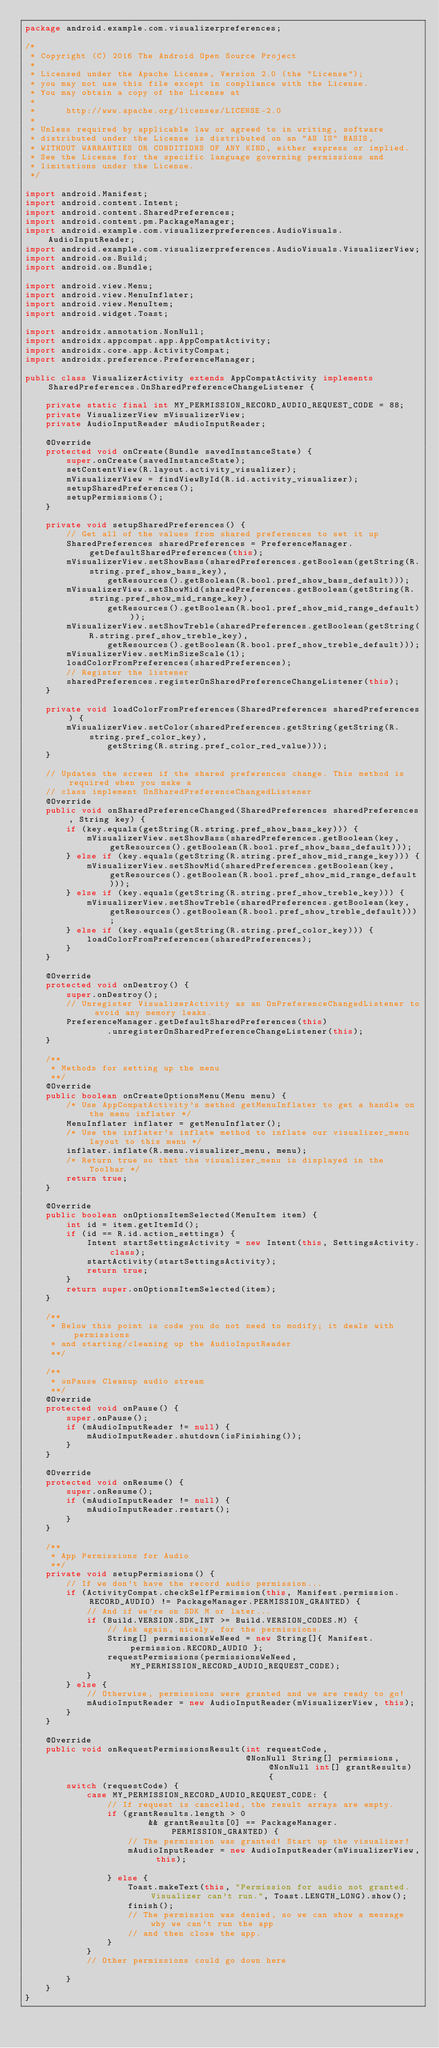<code> <loc_0><loc_0><loc_500><loc_500><_Java_>package android.example.com.visualizerpreferences;

/*
 * Copyright (C) 2016 The Android Open Source Project
 *
 * Licensed under the Apache License, Version 2.0 (the "License");
 * you may not use this file except in compliance with the License.
 * You may obtain a copy of the License at
 *
 *      http://www.apache.org/licenses/LICENSE-2.0
 *
 * Unless required by applicable law or agreed to in writing, software
 * distributed under the License is distributed on an "AS IS" BASIS,
 * WITHOUT WARRANTIES OR CONDITIONS OF ANY KIND, either express or implied.
 * See the License for the specific language governing permissions and
 * limitations under the License.
 */

import android.Manifest;
import android.content.Intent;
import android.content.SharedPreferences;
import android.content.pm.PackageManager;
import android.example.com.visualizerpreferences.AudioVisuals.AudioInputReader;
import android.example.com.visualizerpreferences.AudioVisuals.VisualizerView;
import android.os.Build;
import android.os.Bundle;

import android.view.Menu;
import android.view.MenuInflater;
import android.view.MenuItem;
import android.widget.Toast;

import androidx.annotation.NonNull;
import androidx.appcompat.app.AppCompatActivity;
import androidx.core.app.ActivityCompat;
import androidx.preference.PreferenceManager;

public class VisualizerActivity extends AppCompatActivity implements SharedPreferences.OnSharedPreferenceChangeListener {

    private static final int MY_PERMISSION_RECORD_AUDIO_REQUEST_CODE = 88;
    private VisualizerView mVisualizerView;
    private AudioInputReader mAudioInputReader;

    @Override
    protected void onCreate(Bundle savedInstanceState) {
        super.onCreate(savedInstanceState);
        setContentView(R.layout.activity_visualizer);
        mVisualizerView = findViewById(R.id.activity_visualizer);
        setupSharedPreferences();
        setupPermissions();
    }

    private void setupSharedPreferences() {
        // Get all of the values from shared preferences to set it up
        SharedPreferences sharedPreferences = PreferenceManager.getDefaultSharedPreferences(this);
        mVisualizerView.setShowBass(sharedPreferences.getBoolean(getString(R.string.pref_show_bass_key),
                getResources().getBoolean(R.bool.pref_show_bass_default)));
        mVisualizerView.setShowMid(sharedPreferences.getBoolean(getString(R.string.pref_show_mid_range_key),
                getResources().getBoolean(R.bool.pref_show_mid_range_default)));
        mVisualizerView.setShowTreble(sharedPreferences.getBoolean(getString(R.string.pref_show_treble_key),
                getResources().getBoolean(R.bool.pref_show_treble_default)));
        mVisualizerView.setMinSizeScale(1);
        loadColorFromPreferences(sharedPreferences);
        // Register the listener
        sharedPreferences.registerOnSharedPreferenceChangeListener(this);
    }

    private void loadColorFromPreferences(SharedPreferences sharedPreferences) {
        mVisualizerView.setColor(sharedPreferences.getString(getString(R.string.pref_color_key),
                getString(R.string.pref_color_red_value)));
    }

    // Updates the screen if the shared preferences change. This method is required when you make a
    // class implement OnSharedPreferenceChangedListener
    @Override
    public void onSharedPreferenceChanged(SharedPreferences sharedPreferences, String key) {
        if (key.equals(getString(R.string.pref_show_bass_key))) {
            mVisualizerView.setShowBass(sharedPreferences.getBoolean(key, getResources().getBoolean(R.bool.pref_show_bass_default)));
        } else if (key.equals(getString(R.string.pref_show_mid_range_key))) {
            mVisualizerView.setShowMid(sharedPreferences.getBoolean(key, getResources().getBoolean(R.bool.pref_show_mid_range_default)));
        } else if (key.equals(getString(R.string.pref_show_treble_key))) {
            mVisualizerView.setShowTreble(sharedPreferences.getBoolean(key, getResources().getBoolean(R.bool.pref_show_treble_default)));
        } else if (key.equals(getString(R.string.pref_color_key))) {
            loadColorFromPreferences(sharedPreferences);
        }
    }

    @Override
    protected void onDestroy() {
        super.onDestroy();
        // Unregister VisualizerActivity as an OnPreferenceChangedListener to avoid any memory leaks.
        PreferenceManager.getDefaultSharedPreferences(this)
                .unregisterOnSharedPreferenceChangeListener(this);
    }

    /**
     * Methods for setting up the menu
     **/
    @Override
    public boolean onCreateOptionsMenu(Menu menu) {
        /* Use AppCompatActivity's method getMenuInflater to get a handle on the menu inflater */
        MenuInflater inflater = getMenuInflater();
        /* Use the inflater's inflate method to inflate our visualizer_menu layout to this menu */
        inflater.inflate(R.menu.visualizer_menu, menu);
        /* Return true so that the visualizer_menu is displayed in the Toolbar */
        return true;
    }

    @Override
    public boolean onOptionsItemSelected(MenuItem item) {
        int id = item.getItemId();
        if (id == R.id.action_settings) {
            Intent startSettingsActivity = new Intent(this, SettingsActivity.class);
            startActivity(startSettingsActivity);
            return true;
        }
        return super.onOptionsItemSelected(item);
    }

    /**
     * Below this point is code you do not need to modify; it deals with permissions
     * and starting/cleaning up the AudioInputReader
     **/

    /**
     * onPause Cleanup audio stream
     **/
    @Override
    protected void onPause() {
        super.onPause();
        if (mAudioInputReader != null) {
            mAudioInputReader.shutdown(isFinishing());
        }
    }

    @Override
    protected void onResume() {
        super.onResume();
        if (mAudioInputReader != null) {
            mAudioInputReader.restart();
        }
    }
    
    /**
     * App Permissions for Audio
     **/
    private void setupPermissions() {
        // If we don't have the record audio permission...
        if (ActivityCompat.checkSelfPermission(this, Manifest.permission.RECORD_AUDIO) != PackageManager.PERMISSION_GRANTED) {
            // And if we're on SDK M or later...
            if (Build.VERSION.SDK_INT >= Build.VERSION_CODES.M) {
                // Ask again, nicely, for the permissions.
                String[] permissionsWeNeed = new String[]{ Manifest.permission.RECORD_AUDIO };
                requestPermissions(permissionsWeNeed, MY_PERMISSION_RECORD_AUDIO_REQUEST_CODE);
            }
        } else {
            // Otherwise, permissions were granted and we are ready to go!
            mAudioInputReader = new AudioInputReader(mVisualizerView, this);
        }
    }

    @Override
    public void onRequestPermissionsResult(int requestCode,
                                           @NonNull String[] permissions, @NonNull int[] grantResults) {
        switch (requestCode) {
            case MY_PERMISSION_RECORD_AUDIO_REQUEST_CODE: {
                // If request is cancelled, the result arrays are empty.
                if (grantResults.length > 0
                        && grantResults[0] == PackageManager.PERMISSION_GRANTED) {
                    // The permission was granted! Start up the visualizer!
                    mAudioInputReader = new AudioInputReader(mVisualizerView, this);

                } else {
                    Toast.makeText(this, "Permission for audio not granted. Visualizer can't run.", Toast.LENGTH_LONG).show();
                    finish();
                    // The permission was denied, so we can show a message why we can't run the app
                    // and then close the app.
                }
            }
            // Other permissions could go down here

        }
    }
}</code> 